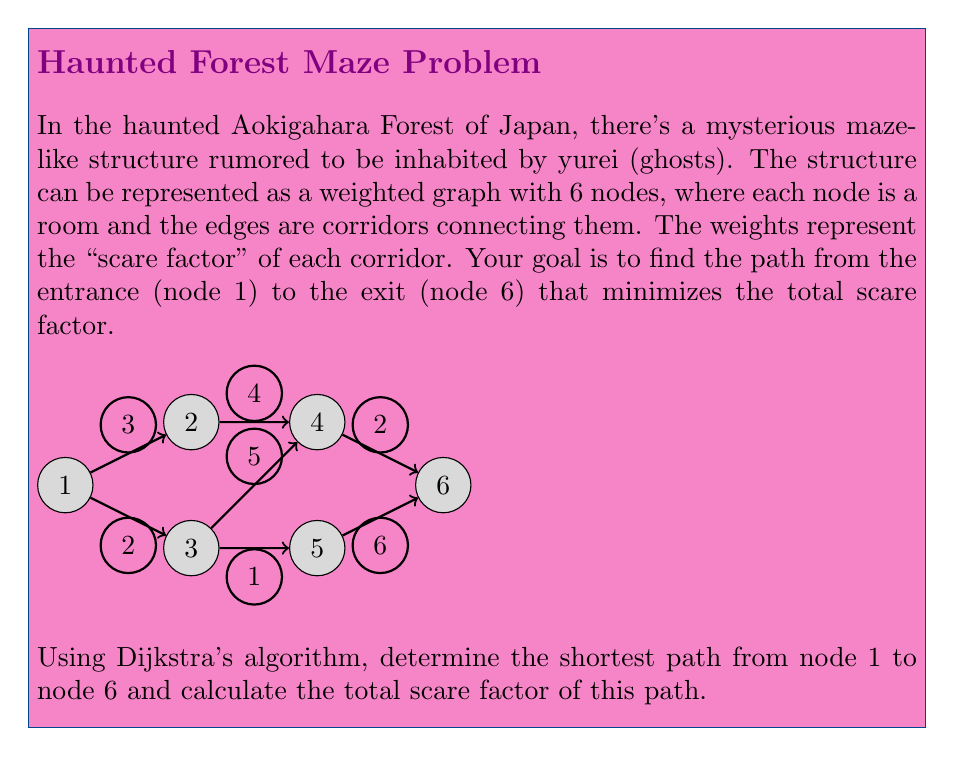Give your solution to this math problem. To solve this problem, we'll use Dijkstra's algorithm to find the shortest path from node 1 to node 6. Here's a step-by-step explanation:

1) Initialize:
   - Distance to node 1 (start) = 0
   - Distance to all other nodes = ∞
   - Set of unvisited nodes = {1, 2, 3, 4, 5, 6}

2) From node 1:
   - Update distance to node 2: min(∞, 0 + 3) = 3
   - Update distance to node 3: min(∞, 0 + 2) = 2
   - Mark node 1 as visited

3) Select node 3 (smallest distance among unvisited nodes):
   - Update distance to node 4: min(∞, 2 + 5) = 7
   - Update distance to node 5: min(∞, 2 + 1) = 3
   - Mark node 3 as visited

4) Select node 2 (distance 3):
   - Update distance to node 4: min(7, 3 + 4) = 7
   - Mark node 2 as visited

5) Select node 5 (distance 3):
   - Update distance to node 6: min(∞, 3 + 6) = 9
   - Mark node 5 as visited

6) Select node 4 (distance 7):
   - Update distance to node 6: min(9, 7 + 2) = 9
   - Mark node 4 as visited

7) Select node 6 (distance 9):
   - This is our destination, so we're done

The shortest path is 1 → 3 → 5 → 6 with a total scare factor of 9.

To verify:
$$ \text{Scare factor} = 2 \text{ (1 to 3)} + 1 \text{ (3 to 5)} + 6 \text{ (5 to 6)} = 9 $$
Answer: Path: 1 → 3 → 5 → 6; Total scare factor: 9 